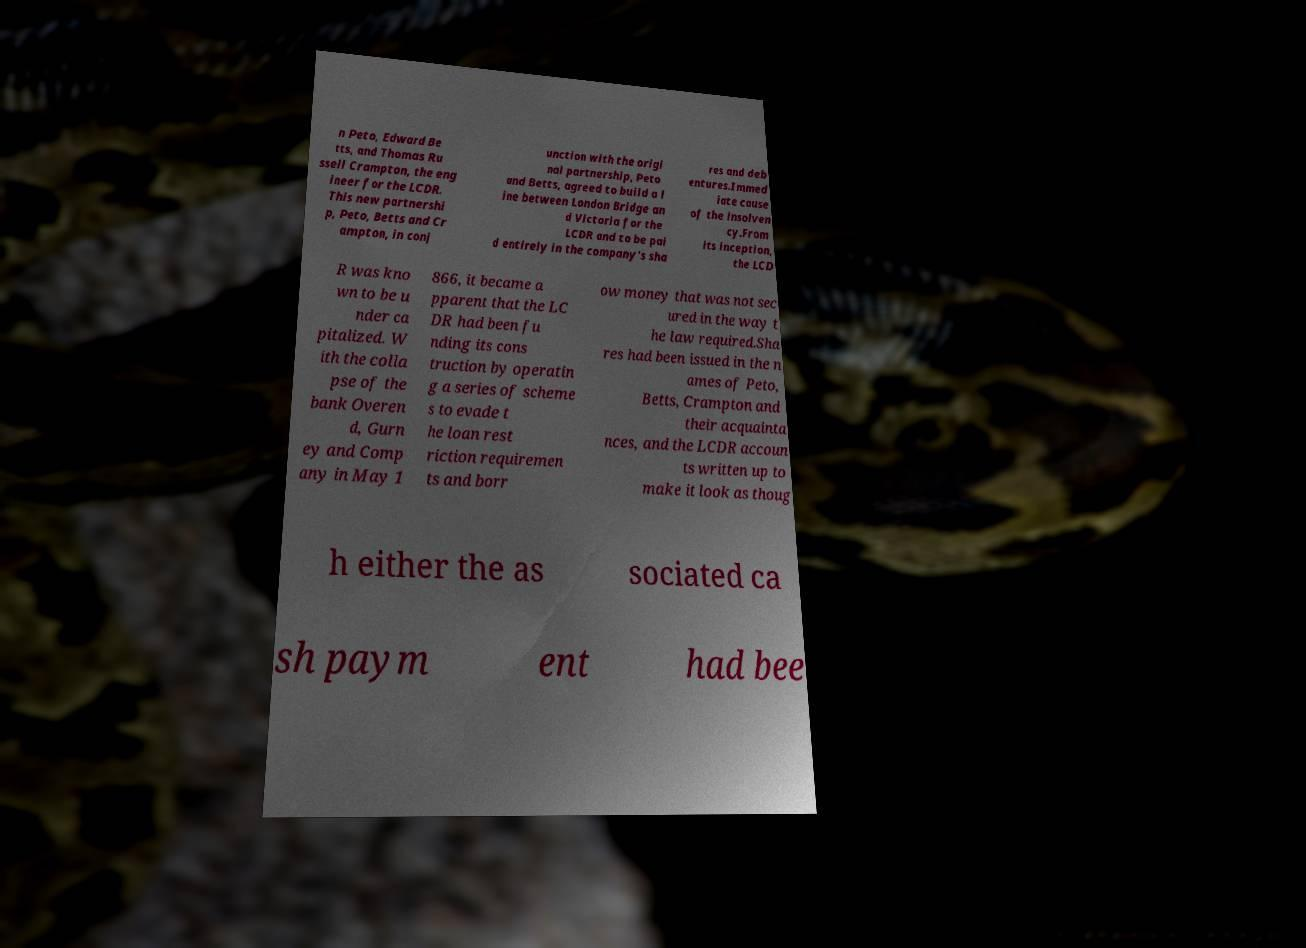For documentation purposes, I need the text within this image transcribed. Could you provide that? n Peto, Edward Be tts, and Thomas Ru ssell Crampton, the eng ineer for the LCDR. This new partnershi p, Peto, Betts and Cr ampton, in conj unction with the origi nal partnership, Peto and Betts, agreed to build a l ine between London Bridge an d Victoria for the LCDR and to be pai d entirely in the company's sha res and deb entures.Immed iate cause of the insolven cy.From its inception, the LCD R was kno wn to be u nder ca pitalized. W ith the colla pse of the bank Overen d, Gurn ey and Comp any in May 1 866, it became a pparent that the LC DR had been fu nding its cons truction by operatin g a series of scheme s to evade t he loan rest riction requiremen ts and borr ow money that was not sec ured in the way t he law required.Sha res had been issued in the n ames of Peto, Betts, Crampton and their acquainta nces, and the LCDR accoun ts written up to make it look as thoug h either the as sociated ca sh paym ent had bee 